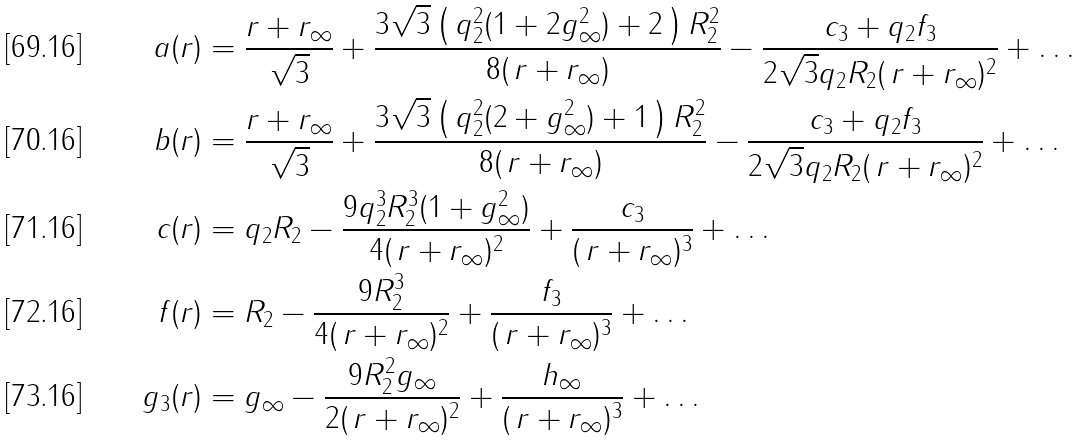Convert formula to latex. <formula><loc_0><loc_0><loc_500><loc_500>a ( r ) & = \frac { r + r _ { \infty } } { \sqrt { 3 } } + \frac { 3 \sqrt { 3 } \left ( \, q _ { 2 } ^ { 2 } ( 1 + 2 g _ { \infty } ^ { 2 } ) + 2 \, \right ) R _ { 2 } ^ { 2 } } { 8 ( \, r + r _ { \infty } ) } - \frac { c _ { 3 } + q _ { 2 } f _ { 3 } } { 2 \sqrt { 3 } q _ { 2 } R _ { 2 } ( \, r + r _ { \infty } ) ^ { 2 } } + \dots \\ b ( r ) & = \frac { r + r _ { \infty } } { \sqrt { 3 } } + \frac { 3 \sqrt { 3 } \left ( \, q _ { 2 } ^ { 2 } ( 2 + g _ { \infty } ^ { 2 } ) + 1 \, \right ) R _ { 2 } ^ { 2 } } { 8 ( \, r + r _ { \infty } ) } - \frac { c _ { 3 } + q _ { 2 } f _ { 3 } } { 2 \sqrt { 3 } q _ { 2 } R _ { 2 } ( \, r + r _ { \infty } ) ^ { 2 } } + \dots \\ c ( r ) & = q _ { 2 } R _ { 2 } - \frac { 9 q _ { 2 } ^ { 3 } R _ { 2 } ^ { 3 } ( 1 + g _ { \infty } ^ { 2 } ) } { 4 ( \, r + r _ { \infty } ) ^ { 2 } } + \frac { c _ { 3 } } { ( \, r + r _ { \infty } ) ^ { 3 } } + \dots \\ f ( r ) & = R _ { 2 } - \frac { 9 R _ { 2 } ^ { 3 } } { 4 ( \, r + r _ { \infty } ) ^ { 2 } } + \frac { f _ { 3 } } { ( \, r + r _ { \infty } ) ^ { 3 } } + \dots \\ g _ { 3 } ( r ) & = g _ { \infty } - \frac { 9 R _ { 2 } ^ { 2 } g _ { \infty } } { 2 ( \, r + r _ { \infty } ) ^ { 2 } } + \frac { h _ { \infty } } { ( \, r + r _ { \infty } ) ^ { 3 } } + \dots</formula> 